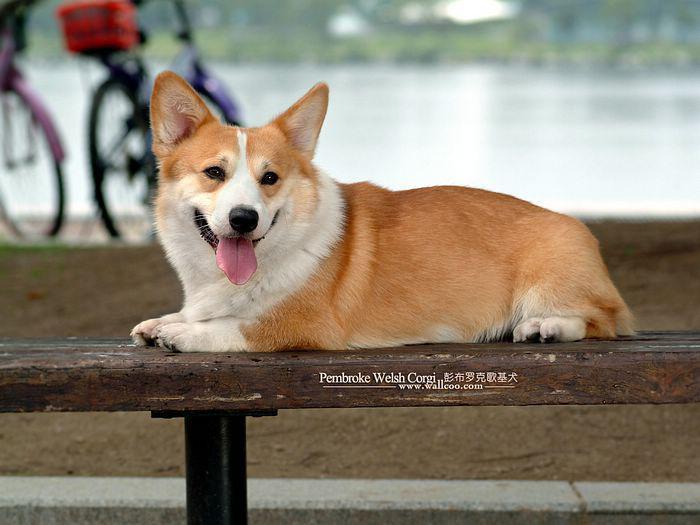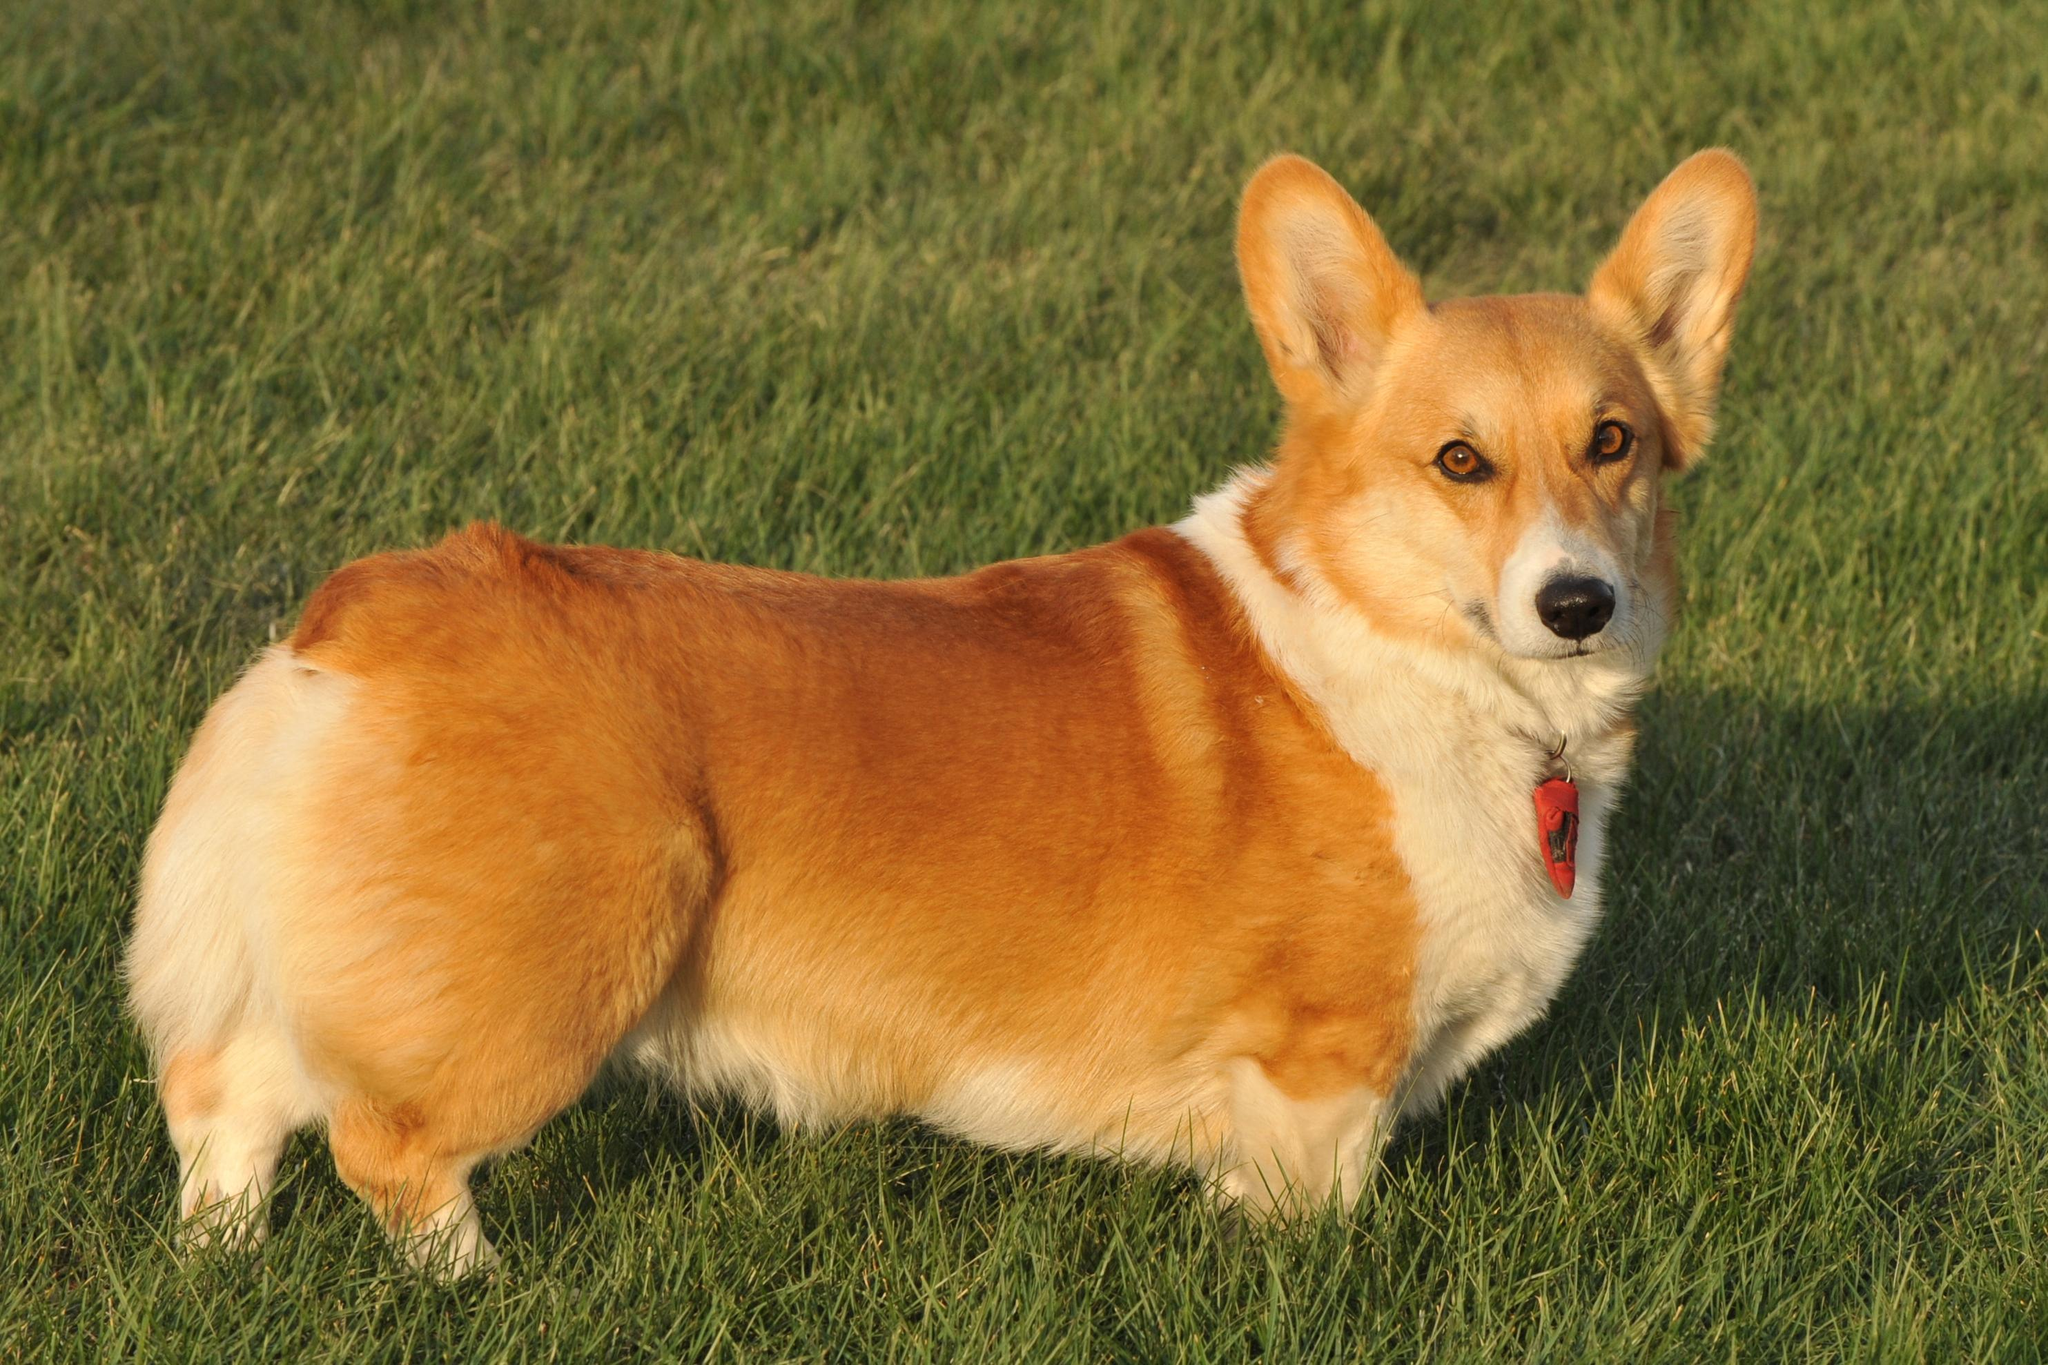The first image is the image on the left, the second image is the image on the right. Evaluate the accuracy of this statement regarding the images: "In the right image, a corgi's body is facing right while it's face is towards the camera.". Is it true? Answer yes or no. Yes. The first image is the image on the left, the second image is the image on the right. Assess this claim about the two images: "The left image features a camera-gazing corgi with its tongue hanging out, and the right image shows a corgi standing rightward in profile, with its head turned forward.". Correct or not? Answer yes or no. Yes. 